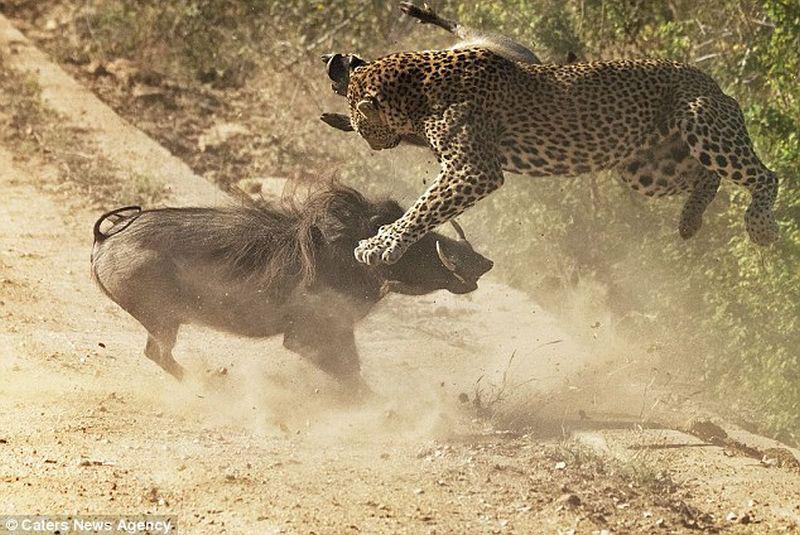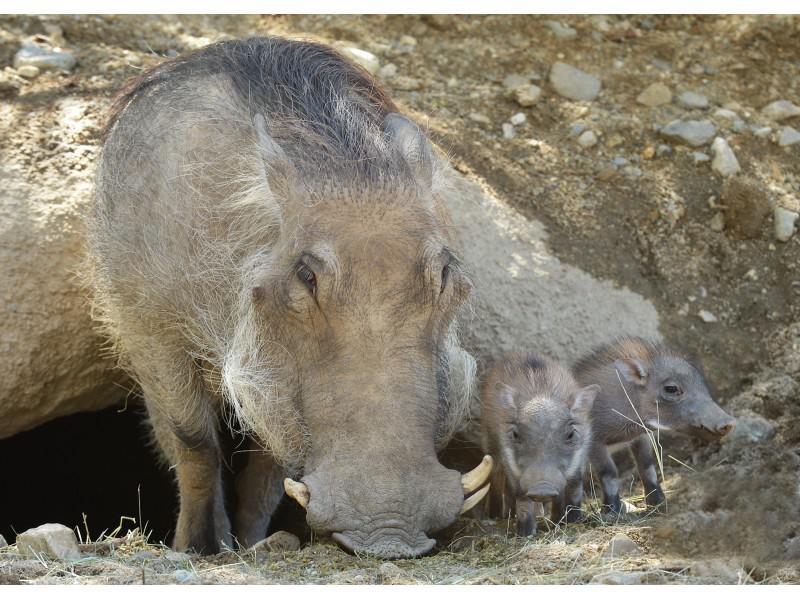The first image is the image on the left, the second image is the image on the right. For the images displayed, is the sentence "An image contains a cheetah attacking a wart hog." factually correct? Answer yes or no. Yes. The first image is the image on the left, the second image is the image on the right. Evaluate the accuracy of this statement regarding the images: "An image includes multiple piglets with an adult warthog standing in profile facing leftward.". Is it true? Answer yes or no. No. 